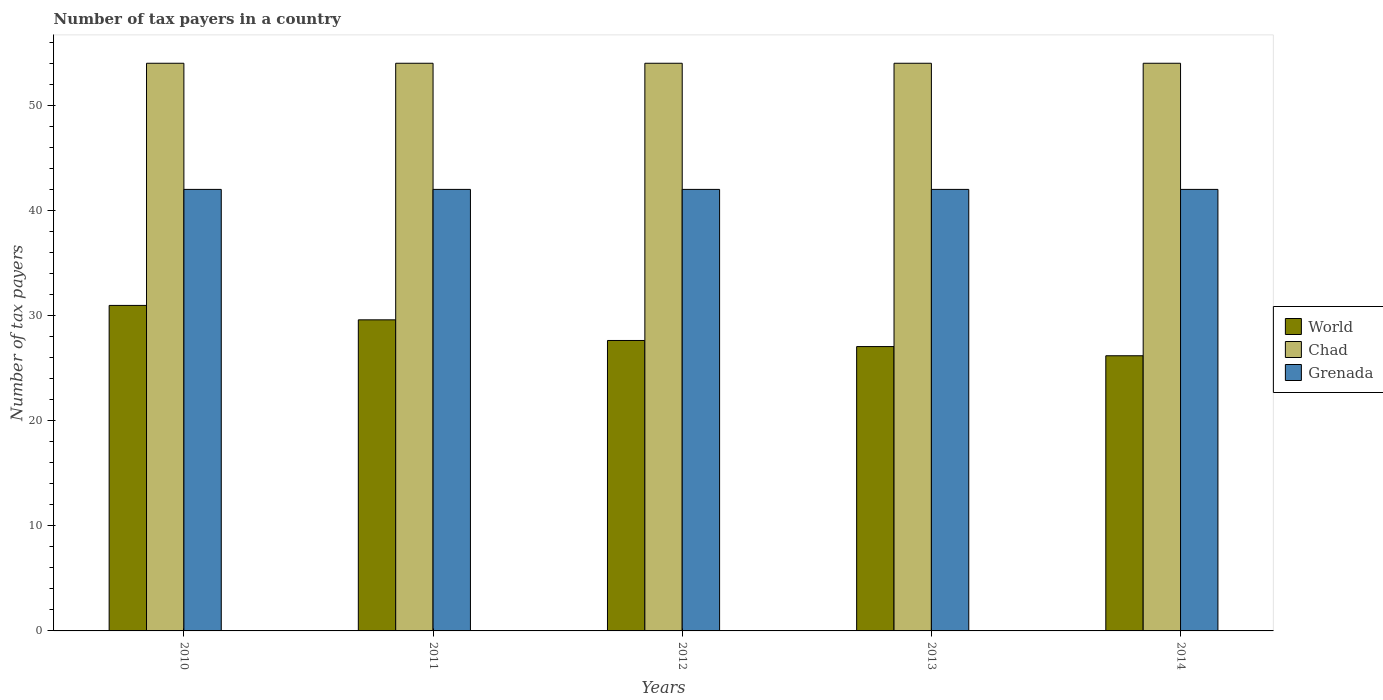How many groups of bars are there?
Your response must be concise. 5. How many bars are there on the 2nd tick from the left?
Give a very brief answer. 3. How many bars are there on the 4th tick from the right?
Offer a terse response. 3. In how many cases, is the number of bars for a given year not equal to the number of legend labels?
Ensure brevity in your answer.  0. What is the number of tax payers in in World in 2012?
Make the answer very short. 27.63. Across all years, what is the maximum number of tax payers in in Grenada?
Give a very brief answer. 42. Across all years, what is the minimum number of tax payers in in Grenada?
Ensure brevity in your answer.  42. In which year was the number of tax payers in in Grenada maximum?
Offer a terse response. 2010. What is the total number of tax payers in in Chad in the graph?
Provide a succinct answer. 270. What is the difference between the number of tax payers in in Chad in 2011 and that in 2012?
Provide a succinct answer. 0. What is the difference between the number of tax payers in in Chad in 2010 and the number of tax payers in in World in 2013?
Make the answer very short. 26.95. In the year 2010, what is the difference between the number of tax payers in in Chad and number of tax payers in in Grenada?
Ensure brevity in your answer.  12. What is the ratio of the number of tax payers in in Grenada in 2011 to that in 2013?
Provide a succinct answer. 1. What is the difference between the highest and the second highest number of tax payers in in Chad?
Give a very brief answer. 0. What is the difference between the highest and the lowest number of tax payers in in Grenada?
Keep it short and to the point. 0. What does the 3rd bar from the left in 2010 represents?
Your answer should be very brief. Grenada. What does the 2nd bar from the right in 2011 represents?
Offer a terse response. Chad. Are all the bars in the graph horizontal?
Your answer should be very brief. No. Are the values on the major ticks of Y-axis written in scientific E-notation?
Your answer should be very brief. No. Does the graph contain any zero values?
Provide a succinct answer. No. Does the graph contain grids?
Give a very brief answer. No. How many legend labels are there?
Give a very brief answer. 3. How are the legend labels stacked?
Offer a very short reply. Vertical. What is the title of the graph?
Ensure brevity in your answer.  Number of tax payers in a country. What is the label or title of the X-axis?
Ensure brevity in your answer.  Years. What is the label or title of the Y-axis?
Make the answer very short. Number of tax payers. What is the Number of tax payers of World in 2010?
Your response must be concise. 30.97. What is the Number of tax payers of Grenada in 2010?
Your answer should be very brief. 42. What is the Number of tax payers in World in 2011?
Your answer should be compact. 29.59. What is the Number of tax payers in Chad in 2011?
Provide a short and direct response. 54. What is the Number of tax payers of Grenada in 2011?
Ensure brevity in your answer.  42. What is the Number of tax payers of World in 2012?
Keep it short and to the point. 27.63. What is the Number of tax payers of Grenada in 2012?
Provide a short and direct response. 42. What is the Number of tax payers in World in 2013?
Ensure brevity in your answer.  27.05. What is the Number of tax payers in Chad in 2013?
Ensure brevity in your answer.  54. What is the Number of tax payers in World in 2014?
Keep it short and to the point. 26.18. What is the Number of tax payers of Chad in 2014?
Make the answer very short. 54. What is the Number of tax payers of Grenada in 2014?
Give a very brief answer. 42. Across all years, what is the maximum Number of tax payers in World?
Offer a very short reply. 30.97. Across all years, what is the maximum Number of tax payers of Chad?
Your answer should be very brief. 54. Across all years, what is the minimum Number of tax payers in World?
Your answer should be very brief. 26.18. Across all years, what is the minimum Number of tax payers in Grenada?
Provide a short and direct response. 42. What is the total Number of tax payers in World in the graph?
Your response must be concise. 141.41. What is the total Number of tax payers in Chad in the graph?
Ensure brevity in your answer.  270. What is the total Number of tax payers in Grenada in the graph?
Your answer should be very brief. 210. What is the difference between the Number of tax payers of World in 2010 and that in 2011?
Make the answer very short. 1.37. What is the difference between the Number of tax payers of World in 2010 and that in 2012?
Offer a terse response. 3.34. What is the difference between the Number of tax payers of Chad in 2010 and that in 2012?
Your answer should be compact. 0. What is the difference between the Number of tax payers in World in 2010 and that in 2013?
Give a very brief answer. 3.92. What is the difference between the Number of tax payers in World in 2010 and that in 2014?
Make the answer very short. 4.79. What is the difference between the Number of tax payers of World in 2011 and that in 2012?
Your answer should be very brief. 1.96. What is the difference between the Number of tax payers of Chad in 2011 and that in 2012?
Offer a very short reply. 0. What is the difference between the Number of tax payers of World in 2011 and that in 2013?
Offer a very short reply. 2.54. What is the difference between the Number of tax payers of Chad in 2011 and that in 2013?
Give a very brief answer. 0. What is the difference between the Number of tax payers of World in 2011 and that in 2014?
Provide a succinct answer. 3.42. What is the difference between the Number of tax payers in Grenada in 2011 and that in 2014?
Provide a short and direct response. 0. What is the difference between the Number of tax payers in World in 2012 and that in 2013?
Give a very brief answer. 0.58. What is the difference between the Number of tax payers in Chad in 2012 and that in 2013?
Ensure brevity in your answer.  0. What is the difference between the Number of tax payers of World in 2012 and that in 2014?
Make the answer very short. 1.45. What is the difference between the Number of tax payers of Chad in 2012 and that in 2014?
Provide a succinct answer. 0. What is the difference between the Number of tax payers of World in 2013 and that in 2014?
Your response must be concise. 0.87. What is the difference between the Number of tax payers in Chad in 2013 and that in 2014?
Your answer should be very brief. 0. What is the difference between the Number of tax payers in Grenada in 2013 and that in 2014?
Ensure brevity in your answer.  0. What is the difference between the Number of tax payers of World in 2010 and the Number of tax payers of Chad in 2011?
Give a very brief answer. -23.03. What is the difference between the Number of tax payers in World in 2010 and the Number of tax payers in Grenada in 2011?
Your answer should be very brief. -11.03. What is the difference between the Number of tax payers in World in 2010 and the Number of tax payers in Chad in 2012?
Give a very brief answer. -23.03. What is the difference between the Number of tax payers in World in 2010 and the Number of tax payers in Grenada in 2012?
Offer a terse response. -11.03. What is the difference between the Number of tax payers in Chad in 2010 and the Number of tax payers in Grenada in 2012?
Make the answer very short. 12. What is the difference between the Number of tax payers in World in 2010 and the Number of tax payers in Chad in 2013?
Provide a succinct answer. -23.03. What is the difference between the Number of tax payers in World in 2010 and the Number of tax payers in Grenada in 2013?
Offer a very short reply. -11.03. What is the difference between the Number of tax payers in World in 2010 and the Number of tax payers in Chad in 2014?
Offer a very short reply. -23.03. What is the difference between the Number of tax payers of World in 2010 and the Number of tax payers of Grenada in 2014?
Give a very brief answer. -11.03. What is the difference between the Number of tax payers of World in 2011 and the Number of tax payers of Chad in 2012?
Your answer should be very brief. -24.41. What is the difference between the Number of tax payers of World in 2011 and the Number of tax payers of Grenada in 2012?
Provide a succinct answer. -12.41. What is the difference between the Number of tax payers in Chad in 2011 and the Number of tax payers in Grenada in 2012?
Offer a very short reply. 12. What is the difference between the Number of tax payers of World in 2011 and the Number of tax payers of Chad in 2013?
Your response must be concise. -24.41. What is the difference between the Number of tax payers in World in 2011 and the Number of tax payers in Grenada in 2013?
Your answer should be compact. -12.41. What is the difference between the Number of tax payers in Chad in 2011 and the Number of tax payers in Grenada in 2013?
Ensure brevity in your answer.  12. What is the difference between the Number of tax payers in World in 2011 and the Number of tax payers in Chad in 2014?
Give a very brief answer. -24.41. What is the difference between the Number of tax payers of World in 2011 and the Number of tax payers of Grenada in 2014?
Your answer should be compact. -12.41. What is the difference between the Number of tax payers of World in 2012 and the Number of tax payers of Chad in 2013?
Offer a very short reply. -26.37. What is the difference between the Number of tax payers in World in 2012 and the Number of tax payers in Grenada in 2013?
Your answer should be very brief. -14.37. What is the difference between the Number of tax payers of World in 2012 and the Number of tax payers of Chad in 2014?
Make the answer very short. -26.37. What is the difference between the Number of tax payers in World in 2012 and the Number of tax payers in Grenada in 2014?
Keep it short and to the point. -14.37. What is the difference between the Number of tax payers of World in 2013 and the Number of tax payers of Chad in 2014?
Make the answer very short. -26.95. What is the difference between the Number of tax payers in World in 2013 and the Number of tax payers in Grenada in 2014?
Provide a short and direct response. -14.95. What is the average Number of tax payers in World per year?
Your response must be concise. 28.28. What is the average Number of tax payers of Grenada per year?
Make the answer very short. 42. In the year 2010, what is the difference between the Number of tax payers of World and Number of tax payers of Chad?
Your answer should be very brief. -23.03. In the year 2010, what is the difference between the Number of tax payers of World and Number of tax payers of Grenada?
Your answer should be compact. -11.03. In the year 2011, what is the difference between the Number of tax payers of World and Number of tax payers of Chad?
Give a very brief answer. -24.41. In the year 2011, what is the difference between the Number of tax payers of World and Number of tax payers of Grenada?
Make the answer very short. -12.41. In the year 2012, what is the difference between the Number of tax payers of World and Number of tax payers of Chad?
Your answer should be very brief. -26.37. In the year 2012, what is the difference between the Number of tax payers of World and Number of tax payers of Grenada?
Your answer should be very brief. -14.37. In the year 2012, what is the difference between the Number of tax payers in Chad and Number of tax payers in Grenada?
Your answer should be very brief. 12. In the year 2013, what is the difference between the Number of tax payers of World and Number of tax payers of Chad?
Give a very brief answer. -26.95. In the year 2013, what is the difference between the Number of tax payers in World and Number of tax payers in Grenada?
Ensure brevity in your answer.  -14.95. In the year 2014, what is the difference between the Number of tax payers of World and Number of tax payers of Chad?
Offer a very short reply. -27.82. In the year 2014, what is the difference between the Number of tax payers of World and Number of tax payers of Grenada?
Give a very brief answer. -15.82. In the year 2014, what is the difference between the Number of tax payers of Chad and Number of tax payers of Grenada?
Provide a succinct answer. 12. What is the ratio of the Number of tax payers in World in 2010 to that in 2011?
Offer a terse response. 1.05. What is the ratio of the Number of tax payers of Chad in 2010 to that in 2011?
Offer a terse response. 1. What is the ratio of the Number of tax payers in Grenada in 2010 to that in 2011?
Your response must be concise. 1. What is the ratio of the Number of tax payers in World in 2010 to that in 2012?
Your answer should be very brief. 1.12. What is the ratio of the Number of tax payers in Chad in 2010 to that in 2012?
Provide a short and direct response. 1. What is the ratio of the Number of tax payers of World in 2010 to that in 2013?
Keep it short and to the point. 1.14. What is the ratio of the Number of tax payers of Chad in 2010 to that in 2013?
Keep it short and to the point. 1. What is the ratio of the Number of tax payers in Grenada in 2010 to that in 2013?
Your response must be concise. 1. What is the ratio of the Number of tax payers of World in 2010 to that in 2014?
Ensure brevity in your answer.  1.18. What is the ratio of the Number of tax payers of Chad in 2010 to that in 2014?
Your answer should be compact. 1. What is the ratio of the Number of tax payers of World in 2011 to that in 2012?
Offer a very short reply. 1.07. What is the ratio of the Number of tax payers in Grenada in 2011 to that in 2012?
Make the answer very short. 1. What is the ratio of the Number of tax payers in World in 2011 to that in 2013?
Provide a succinct answer. 1.09. What is the ratio of the Number of tax payers in Grenada in 2011 to that in 2013?
Provide a short and direct response. 1. What is the ratio of the Number of tax payers in World in 2011 to that in 2014?
Offer a very short reply. 1.13. What is the ratio of the Number of tax payers of Chad in 2011 to that in 2014?
Offer a very short reply. 1. What is the ratio of the Number of tax payers in World in 2012 to that in 2013?
Provide a short and direct response. 1.02. What is the ratio of the Number of tax payers in Chad in 2012 to that in 2013?
Offer a very short reply. 1. What is the ratio of the Number of tax payers of World in 2012 to that in 2014?
Ensure brevity in your answer.  1.06. What is the ratio of the Number of tax payers of Grenada in 2012 to that in 2014?
Offer a very short reply. 1. What is the ratio of the Number of tax payers in World in 2013 to that in 2014?
Make the answer very short. 1.03. What is the ratio of the Number of tax payers of Grenada in 2013 to that in 2014?
Give a very brief answer. 1. What is the difference between the highest and the second highest Number of tax payers of World?
Keep it short and to the point. 1.37. What is the difference between the highest and the second highest Number of tax payers in Chad?
Make the answer very short. 0. What is the difference between the highest and the lowest Number of tax payers in World?
Provide a short and direct response. 4.79. What is the difference between the highest and the lowest Number of tax payers of Chad?
Your response must be concise. 0. 